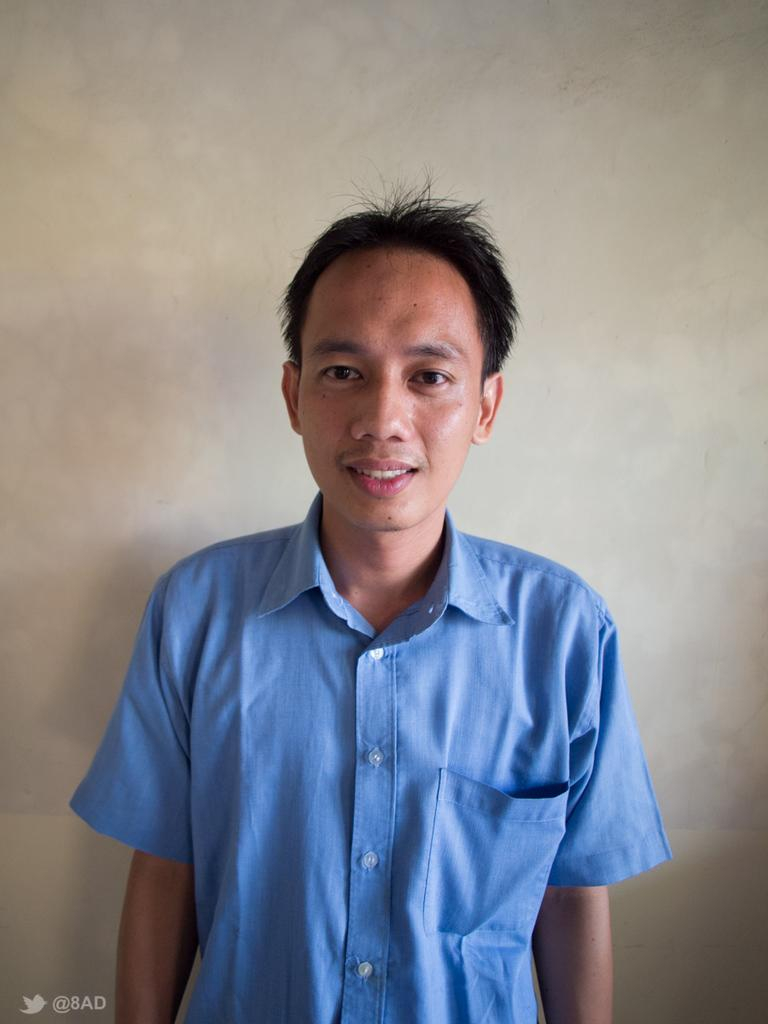What is the main subject of the image? There is a person standing in the center of the image. Can you describe the background of the image? There is a wall in the background of the image. What type of field can be seen in the image? There is no field present in the image; it features a person standing in front of a wall. 